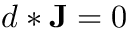Convert formula to latex. <formula><loc_0><loc_0><loc_500><loc_500>d * J = 0</formula> 